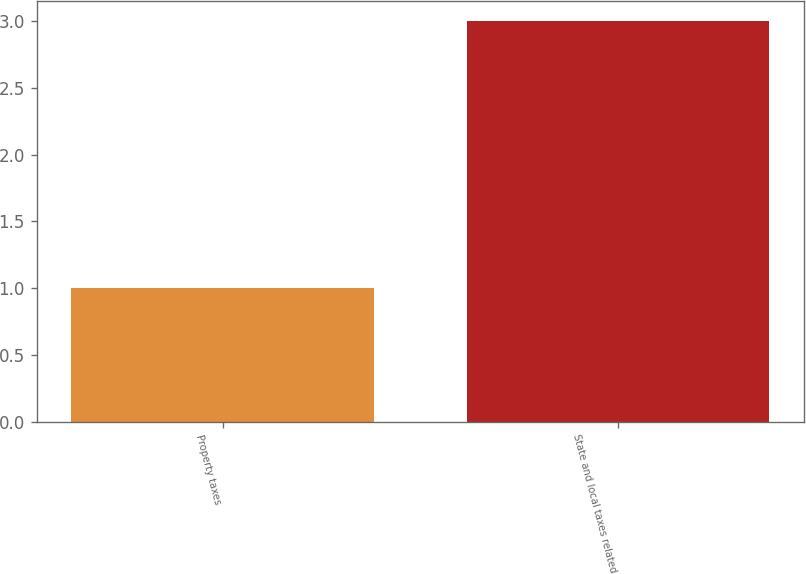Convert chart. <chart><loc_0><loc_0><loc_500><loc_500><bar_chart><fcel>Property taxes<fcel>State and local taxes related<nl><fcel>1<fcel>3<nl></chart> 